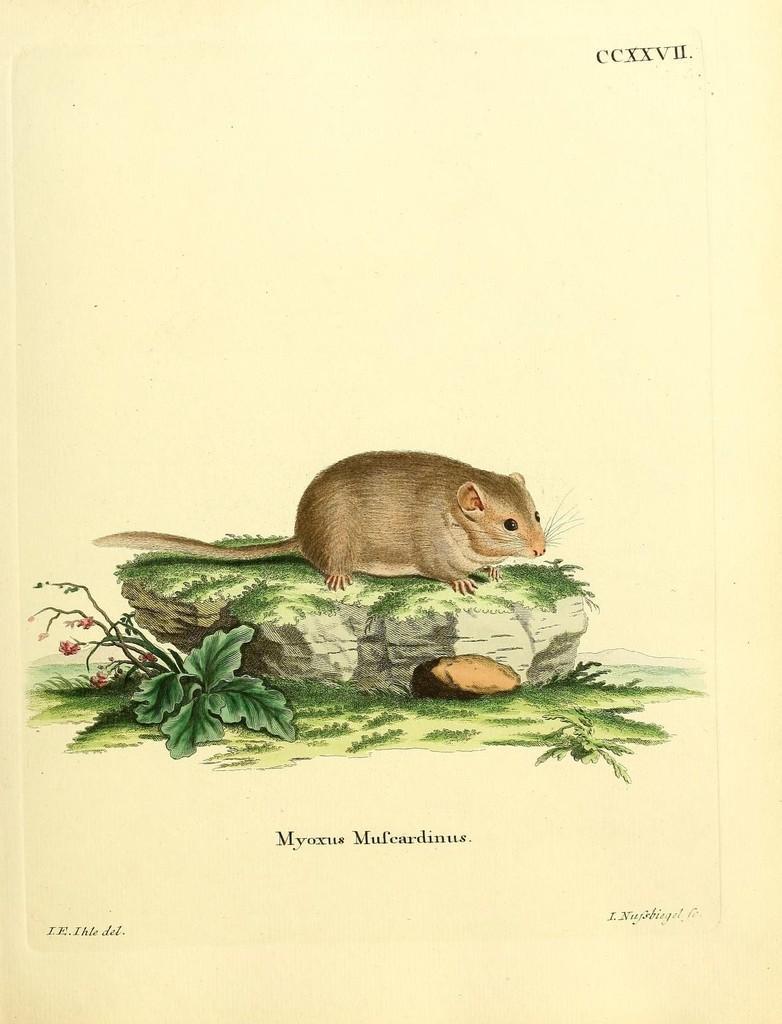Please provide a concise description of this image. In this image I can see a paper in white color, in the paper I can see a stone, on the stone I can see a rat in brown color, left I can see small plant in green color. 